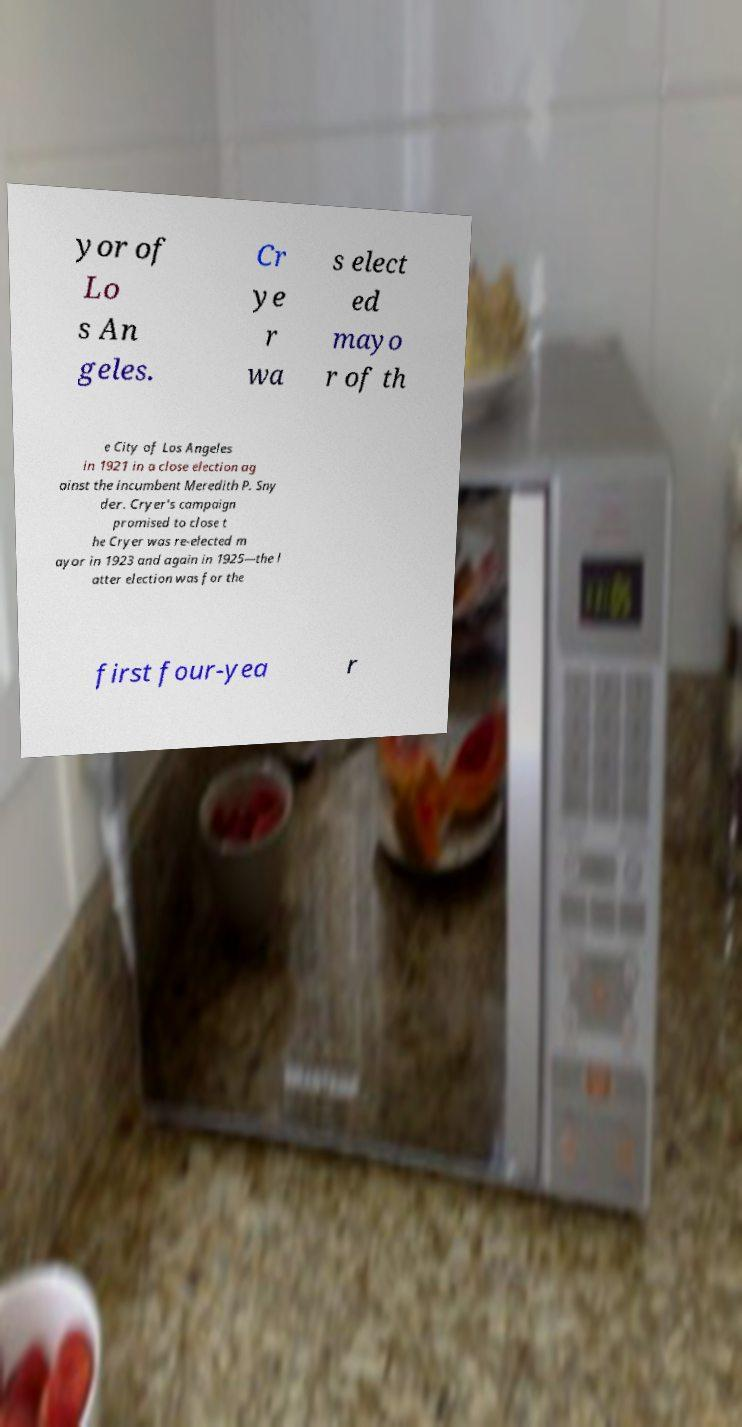Could you extract and type out the text from this image? yor of Lo s An geles. Cr ye r wa s elect ed mayo r of th e City of Los Angeles in 1921 in a close election ag ainst the incumbent Meredith P. Sny der. Cryer's campaign promised to close t he Cryer was re-elected m ayor in 1923 and again in 1925—the l atter election was for the first four-yea r 